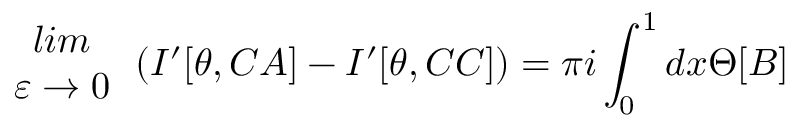<formula> <loc_0><loc_0><loc_500><loc_500>\begin{array} { c } { l i m } \\ { \varepsilon \rightarrow 0 } \end{array} \left ( I ^ { \prime } [ \theta , C A ] - I ^ { \prime } [ \theta , C C ] \right ) = \pi i \int _ { 0 } ^ { 1 } d x \Theta [ B ]</formula> 